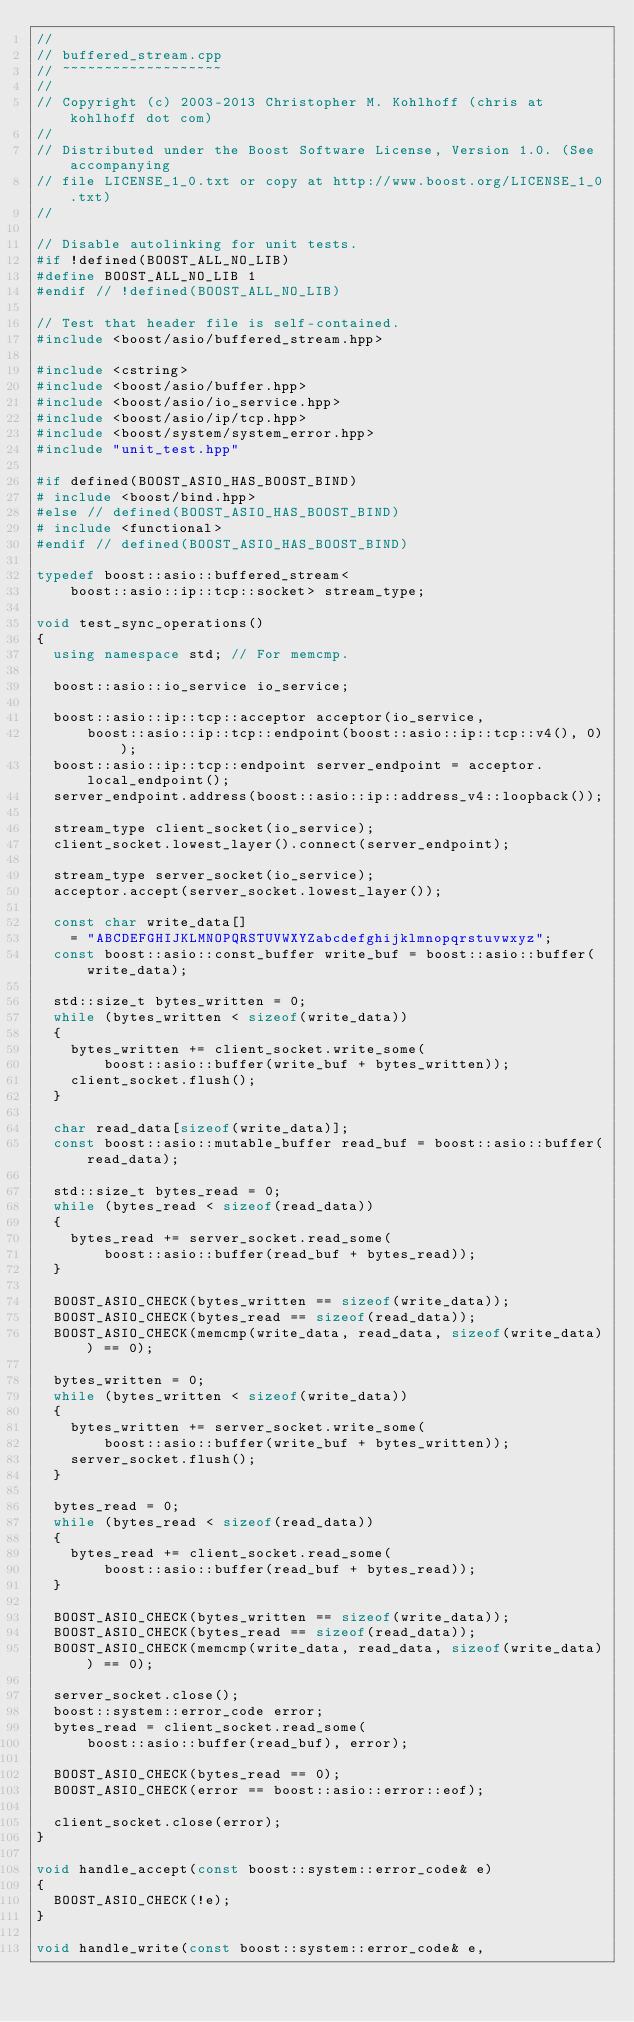Convert code to text. <code><loc_0><loc_0><loc_500><loc_500><_C++_>//
// buffered_stream.cpp
// ~~~~~~~~~~~~~~~~~~~
//
// Copyright (c) 2003-2013 Christopher M. Kohlhoff (chris at kohlhoff dot com)
//
// Distributed under the Boost Software License, Version 1.0. (See accompanying
// file LICENSE_1_0.txt or copy at http://www.boost.org/LICENSE_1_0.txt)
//

// Disable autolinking for unit tests.
#if !defined(BOOST_ALL_NO_LIB)
#define BOOST_ALL_NO_LIB 1
#endif // !defined(BOOST_ALL_NO_LIB)

// Test that header file is self-contained.
#include <boost/asio/buffered_stream.hpp>

#include <cstring>
#include <boost/asio/buffer.hpp>
#include <boost/asio/io_service.hpp>
#include <boost/asio/ip/tcp.hpp>
#include <boost/system/system_error.hpp>
#include "unit_test.hpp"

#if defined(BOOST_ASIO_HAS_BOOST_BIND)
# include <boost/bind.hpp>
#else // defined(BOOST_ASIO_HAS_BOOST_BIND)
# include <functional>
#endif // defined(BOOST_ASIO_HAS_BOOST_BIND)

typedef boost::asio::buffered_stream<
    boost::asio::ip::tcp::socket> stream_type;

void test_sync_operations()
{
  using namespace std; // For memcmp.

  boost::asio::io_service io_service;

  boost::asio::ip::tcp::acceptor acceptor(io_service,
      boost::asio::ip::tcp::endpoint(boost::asio::ip::tcp::v4(), 0));
  boost::asio::ip::tcp::endpoint server_endpoint = acceptor.local_endpoint();
  server_endpoint.address(boost::asio::ip::address_v4::loopback());

  stream_type client_socket(io_service);
  client_socket.lowest_layer().connect(server_endpoint);

  stream_type server_socket(io_service);
  acceptor.accept(server_socket.lowest_layer());

  const char write_data[]
    = "ABCDEFGHIJKLMNOPQRSTUVWXYZabcdefghijklmnopqrstuvwxyz";
  const boost::asio::const_buffer write_buf = boost::asio::buffer(write_data);

  std::size_t bytes_written = 0;
  while (bytes_written < sizeof(write_data))
  {
    bytes_written += client_socket.write_some(
        boost::asio::buffer(write_buf + bytes_written));
    client_socket.flush();
  }

  char read_data[sizeof(write_data)];
  const boost::asio::mutable_buffer read_buf = boost::asio::buffer(read_data);

  std::size_t bytes_read = 0;
  while (bytes_read < sizeof(read_data))
  {
    bytes_read += server_socket.read_some(
        boost::asio::buffer(read_buf + bytes_read));
  }

  BOOST_ASIO_CHECK(bytes_written == sizeof(write_data));
  BOOST_ASIO_CHECK(bytes_read == sizeof(read_data));
  BOOST_ASIO_CHECK(memcmp(write_data, read_data, sizeof(write_data)) == 0);

  bytes_written = 0;
  while (bytes_written < sizeof(write_data))
  {
    bytes_written += server_socket.write_some(
        boost::asio::buffer(write_buf + bytes_written));
    server_socket.flush();
  }

  bytes_read = 0;
  while (bytes_read < sizeof(read_data))
  {
    bytes_read += client_socket.read_some(
        boost::asio::buffer(read_buf + bytes_read));
  }

  BOOST_ASIO_CHECK(bytes_written == sizeof(write_data));
  BOOST_ASIO_CHECK(bytes_read == sizeof(read_data));
  BOOST_ASIO_CHECK(memcmp(write_data, read_data, sizeof(write_data)) == 0);

  server_socket.close();
  boost::system::error_code error;
  bytes_read = client_socket.read_some(
      boost::asio::buffer(read_buf), error);

  BOOST_ASIO_CHECK(bytes_read == 0);
  BOOST_ASIO_CHECK(error == boost::asio::error::eof);

  client_socket.close(error);
}

void handle_accept(const boost::system::error_code& e)
{
  BOOST_ASIO_CHECK(!e);
}

void handle_write(const boost::system::error_code& e,</code> 